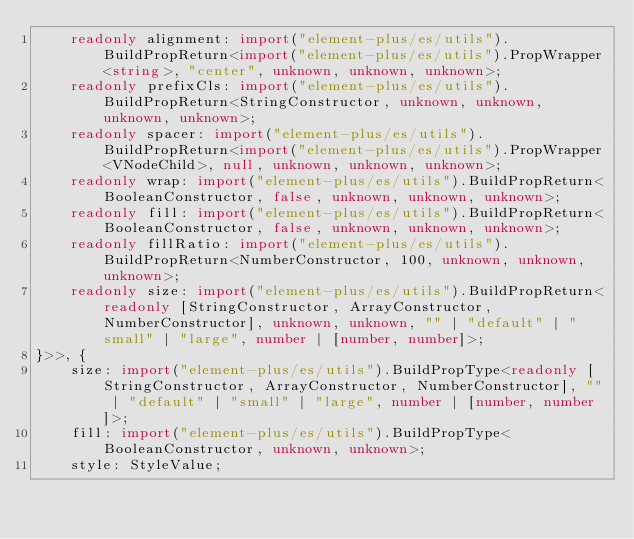Convert code to text. <code><loc_0><loc_0><loc_500><loc_500><_TypeScript_>    readonly alignment: import("element-plus/es/utils").BuildPropReturn<import("element-plus/es/utils").PropWrapper<string>, "center", unknown, unknown, unknown>;
    readonly prefixCls: import("element-plus/es/utils").BuildPropReturn<StringConstructor, unknown, unknown, unknown, unknown>;
    readonly spacer: import("element-plus/es/utils").BuildPropReturn<import("element-plus/es/utils").PropWrapper<VNodeChild>, null, unknown, unknown, unknown>;
    readonly wrap: import("element-plus/es/utils").BuildPropReturn<BooleanConstructor, false, unknown, unknown, unknown>;
    readonly fill: import("element-plus/es/utils").BuildPropReturn<BooleanConstructor, false, unknown, unknown, unknown>;
    readonly fillRatio: import("element-plus/es/utils").BuildPropReturn<NumberConstructor, 100, unknown, unknown, unknown>;
    readonly size: import("element-plus/es/utils").BuildPropReturn<readonly [StringConstructor, ArrayConstructor, NumberConstructor], unknown, unknown, "" | "default" | "small" | "large", number | [number, number]>;
}>>, {
    size: import("element-plus/es/utils").BuildPropType<readonly [StringConstructor, ArrayConstructor, NumberConstructor], "" | "default" | "small" | "large", number | [number, number]>;
    fill: import("element-plus/es/utils").BuildPropType<BooleanConstructor, unknown, unknown>;
    style: StyleValue;</code> 